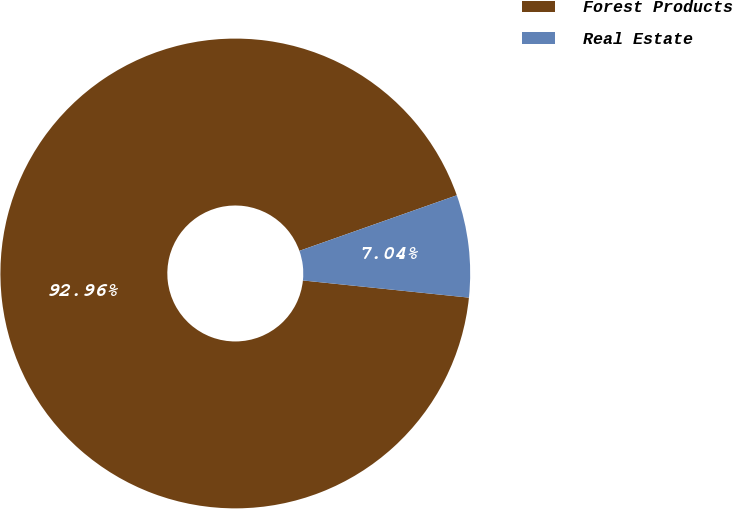<chart> <loc_0><loc_0><loc_500><loc_500><pie_chart><fcel>Forest Products<fcel>Real Estate<nl><fcel>92.96%<fcel>7.04%<nl></chart> 